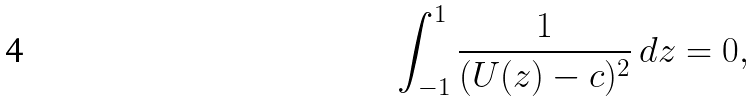Convert formula to latex. <formula><loc_0><loc_0><loc_500><loc_500>\int _ { - 1 } ^ { 1 } \frac { 1 } { ( U ( z ) - c ) ^ { 2 } } \, d z = 0 ,</formula> 